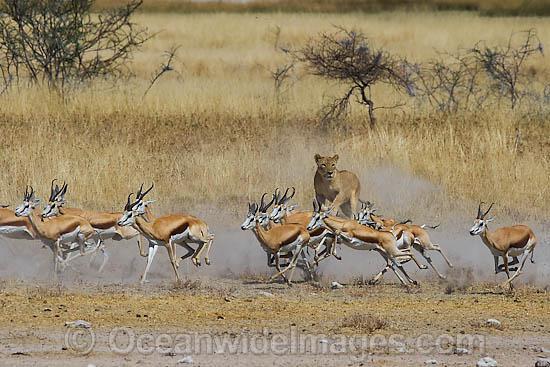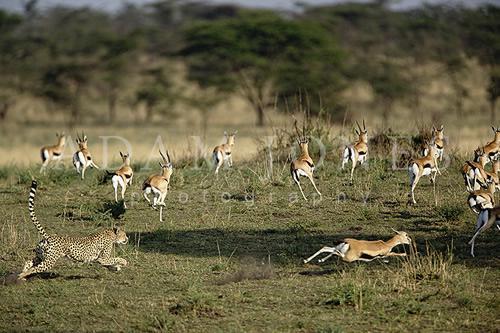The first image is the image on the left, the second image is the image on the right. Examine the images to the left and right. Is the description "In the left image there is one cheetah and it is running towards the left." accurate? Answer yes or no. No. The first image is the image on the left, the second image is the image on the right. Evaluate the accuracy of this statement regarding the images: "At least one of the images contains a single large cat chasing a single animal with no other animals present.". Is it true? Answer yes or no. No. 